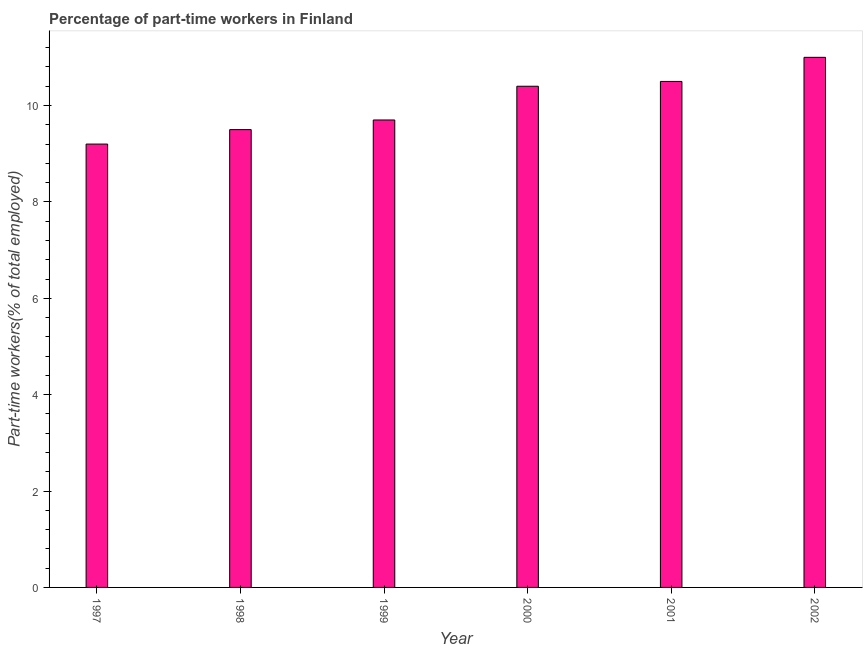Does the graph contain any zero values?
Give a very brief answer. No. What is the title of the graph?
Offer a terse response. Percentage of part-time workers in Finland. What is the label or title of the Y-axis?
Offer a terse response. Part-time workers(% of total employed). What is the percentage of part-time workers in 2002?
Offer a terse response. 11. Across all years, what is the minimum percentage of part-time workers?
Your answer should be compact. 9.2. In which year was the percentage of part-time workers minimum?
Provide a succinct answer. 1997. What is the sum of the percentage of part-time workers?
Your answer should be very brief. 60.3. What is the difference between the percentage of part-time workers in 1997 and 1998?
Make the answer very short. -0.3. What is the average percentage of part-time workers per year?
Ensure brevity in your answer.  10.05. What is the median percentage of part-time workers?
Offer a terse response. 10.05. In how many years, is the percentage of part-time workers greater than 6 %?
Provide a short and direct response. 6. Is the percentage of part-time workers in 2000 less than that in 2002?
Your answer should be compact. Yes. Is the difference between the percentage of part-time workers in 1998 and 2002 greater than the difference between any two years?
Make the answer very short. No. What is the difference between the highest and the second highest percentage of part-time workers?
Keep it short and to the point. 0.5. Is the sum of the percentage of part-time workers in 2000 and 2001 greater than the maximum percentage of part-time workers across all years?
Provide a short and direct response. Yes. How many bars are there?
Offer a terse response. 6. What is the difference between two consecutive major ticks on the Y-axis?
Your response must be concise. 2. Are the values on the major ticks of Y-axis written in scientific E-notation?
Your response must be concise. No. What is the Part-time workers(% of total employed) in 1997?
Provide a short and direct response. 9.2. What is the Part-time workers(% of total employed) in 1998?
Make the answer very short. 9.5. What is the Part-time workers(% of total employed) in 1999?
Ensure brevity in your answer.  9.7. What is the Part-time workers(% of total employed) of 2000?
Provide a short and direct response. 10.4. What is the difference between the Part-time workers(% of total employed) in 1997 and 1999?
Keep it short and to the point. -0.5. What is the difference between the Part-time workers(% of total employed) in 1997 and 2000?
Give a very brief answer. -1.2. What is the difference between the Part-time workers(% of total employed) in 1997 and 2002?
Your answer should be very brief. -1.8. What is the difference between the Part-time workers(% of total employed) in 1998 and 1999?
Your answer should be very brief. -0.2. What is the difference between the Part-time workers(% of total employed) in 1998 and 2001?
Offer a terse response. -1. What is the difference between the Part-time workers(% of total employed) in 1998 and 2002?
Provide a short and direct response. -1.5. What is the difference between the Part-time workers(% of total employed) in 1999 and 2000?
Offer a terse response. -0.7. What is the difference between the Part-time workers(% of total employed) in 1999 and 2001?
Keep it short and to the point. -0.8. What is the difference between the Part-time workers(% of total employed) in 2000 and 2002?
Give a very brief answer. -0.6. What is the difference between the Part-time workers(% of total employed) in 2001 and 2002?
Keep it short and to the point. -0.5. What is the ratio of the Part-time workers(% of total employed) in 1997 to that in 1999?
Give a very brief answer. 0.95. What is the ratio of the Part-time workers(% of total employed) in 1997 to that in 2000?
Offer a very short reply. 0.89. What is the ratio of the Part-time workers(% of total employed) in 1997 to that in 2001?
Offer a terse response. 0.88. What is the ratio of the Part-time workers(% of total employed) in 1997 to that in 2002?
Your answer should be very brief. 0.84. What is the ratio of the Part-time workers(% of total employed) in 1998 to that in 2000?
Provide a succinct answer. 0.91. What is the ratio of the Part-time workers(% of total employed) in 1998 to that in 2001?
Offer a very short reply. 0.91. What is the ratio of the Part-time workers(% of total employed) in 1998 to that in 2002?
Keep it short and to the point. 0.86. What is the ratio of the Part-time workers(% of total employed) in 1999 to that in 2000?
Your answer should be compact. 0.93. What is the ratio of the Part-time workers(% of total employed) in 1999 to that in 2001?
Offer a very short reply. 0.92. What is the ratio of the Part-time workers(% of total employed) in 1999 to that in 2002?
Keep it short and to the point. 0.88. What is the ratio of the Part-time workers(% of total employed) in 2000 to that in 2001?
Your response must be concise. 0.99. What is the ratio of the Part-time workers(% of total employed) in 2000 to that in 2002?
Keep it short and to the point. 0.94. What is the ratio of the Part-time workers(% of total employed) in 2001 to that in 2002?
Provide a succinct answer. 0.95. 